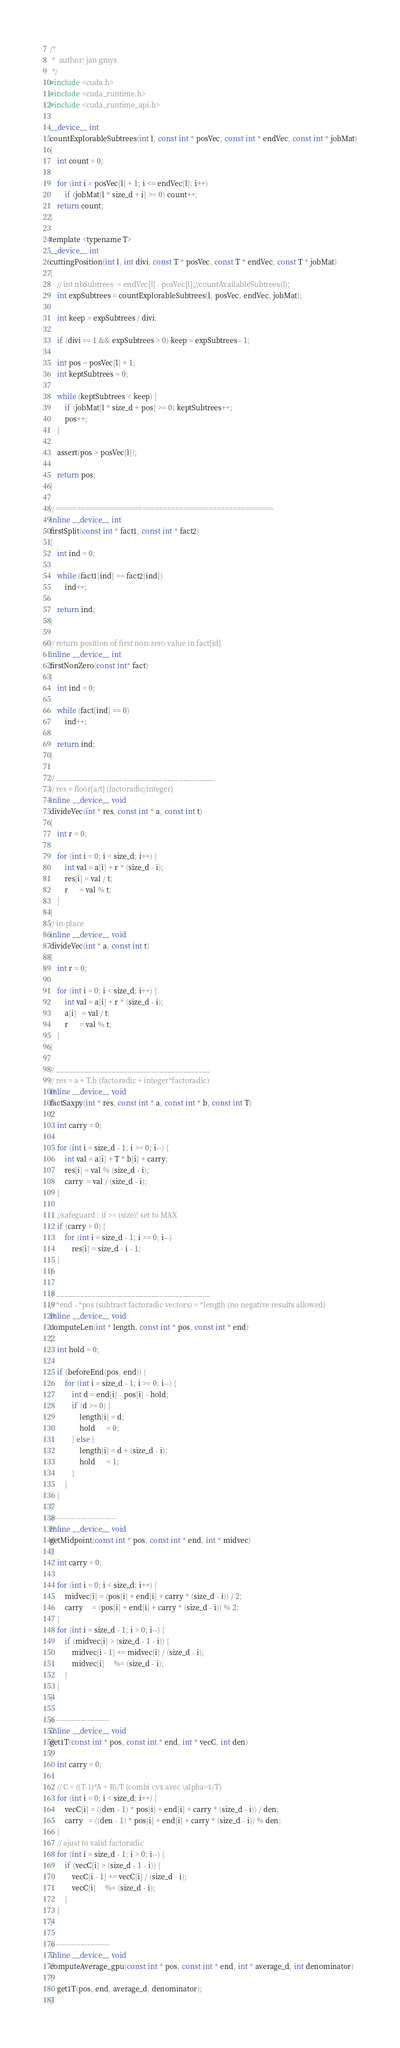<code> <loc_0><loc_0><loc_500><loc_500><_Cuda_>/*
 *  author: jan gmys
 */
#include <cuda.h>
#include <cuda_runtime.h>
#include <cuda_runtime_api.h>

__device__ int
countExplorableSubtrees(int l, const int * posVec, const int * endVec, const int * jobMat)
{
    int count = 0;

    for (int i = posVec[l] + 1; i <= endVec[l]; i++)
        if (jobMat[l * size_d + i] >= 0) count++;
    return count;
}

template <typename T>
__device__ int
cuttingPosition(int l, int divi, const T * posVec, const T * endVec, const T * jobMat)
{
    // int nbSubtrees  = endVec[l] - posVec[l];//countAvailableSubtrees(l);
    int expSubtrees = countExplorableSubtrees(l, posVec, endVec, jobMat);

    int keep = expSubtrees / divi;

    if (divi == 1 && expSubtrees > 0) keep = expSubtrees - 1;

    int pos = posVec[l] + 1;
    int keptSubtrees = 0;

    while (keptSubtrees < keep) {
        if (jobMat[l * size_d + pos] >= 0) keptSubtrees++;
        pos++;
    }

    assert(pos > posVec[l]);

    return pos;
}

// =====================================================
inline __device__ int
firstSplit(const int * fact1, const int * fact2)
{
    int ind = 0;

    while (fact1[ind] == fact2[ind])
        ind++;

    return ind;
}

// return position of first non-zero value in fact[id]
inline __device__ int
firstNonZero(const int* fact)
{
    int ind = 0;

    while (fact[ind] == 0)
        ind++;

    return ind;
}

// ________________________________________
// res = floor[a/t] (factoradic/integer)
inline __device__ void
divideVec(int * res, const int * a, const int t)
{
    int r = 0;

    for (int i = 0; i < size_d; i++) {
        int val = a[i] + r * (size_d - i);
        res[i] = val / t;
        r      = val % t;
    }
}
// in-place
inline __device__ void
divideVec(int * a, const int t)
{
    int r = 0;

    for (int i = 0; i < size_d; i++) {
        int val = a[i] + r * (size_d - i);
        a[i]   = val / t;
        r      = val % t;
    }
}

// _______________________________________
// res = a + T.b (factoradic + integer*factoradic)
inline __device__ void
factSaxpy(int * res, const int * a, const int * b, const int T)
{
    int carry = 0;

    for (int i = size_d - 1; i >= 0; i--) {
        int val = a[i] + T * b[i] + carry;
        res[i] = val % (size_d - i);
        carry  = val / (size_d - i);
    }

    //safeguard : if >= (size)! set to MAX
    if (carry > 0) {
        for (int i = size_d - 1; i >= 0; i--)
            res[i] = size_d - i - 1;
    }
}

// _______________________________________
// *end - *pos (subtract factoradic vectors) = *length (no negative results allowed)
inline __device__ void
computeLen(int * length, const int * pos, const int * end)
{
    int hold = 0;

    if (beforeEnd(pos, end)) {
        for (int i = size_d - 1; i >= 0; i--) {
            int d = end[i] - pos[i] - hold;
            if (d >= 0) {
                length[i] = d;
                hold      = 0;
            } else {
                length[i] = d + (size_d - i);
                hold      = 1;
            }
        }
    }
}
// -------------------------
inline __device__ void
getMidpoint(const int * pos, const int * end, int * midvec)
{
    int carry = 0;

    for (int i = 0; i < size_d; i++) {
        midvec[i] = (pos[i] + end[i] + carry * (size_d - i)) / 2;
        carry     = (pos[i] + end[i] + carry * (size_d - i)) % 2;
    }
    for (int i = size_d - 1; i > 0; i--) {
        if (midvec[i] > (size_d - 1 - i)) {
            midvec[i - 1] += midvec[i] / (size_d - i);
            midvec[i]     %= (size_d - i);
        }
    }
}

// ----------------------
inline __device__ void
get1T(const int * pos, const int * end, int * vecC, int den)
{
    int carry = 0;

    // C = ((T-1)*A + B)/T (combi cvx avec \alpha=1/T)
    for (int i = 0; i < size_d; i++) {
        vecC[i] = ((den - 1) * pos[i] + end[i] + carry * (size_d - i)) / den;
        carry   = ((den - 1) * pos[i] + end[i] + carry * (size_d - i)) % den;
    }
    // ajust to valid factoradic
    for (int i = size_d - 1; i > 0; i--) {
        if (vecC[i] > (size_d - 1 - i)) {
            vecC[i - 1] += vecC[i] / (size_d - i);
            vecC[i]     %= (size_d - i);
        }
    }
}

// ----------------------
inline __device__ void
computeAverage_gpu(const int * pos, const int * end, int * average_d, int denominator)
{
    get1T(pos, end, average_d, denominator);
}
</code> 